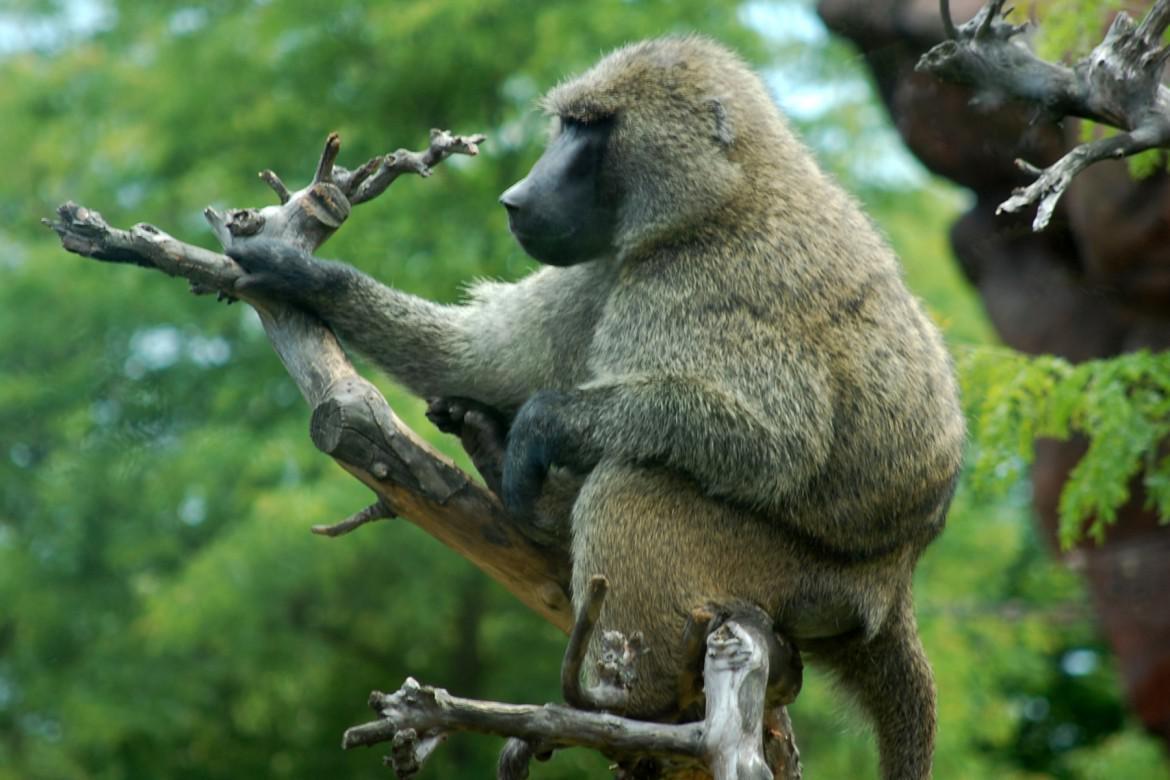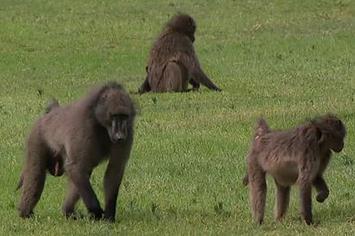The first image is the image on the left, the second image is the image on the right. Evaluate the accuracy of this statement regarding the images: "There are at least two monkeys in the image on the right.". Is it true? Answer yes or no. Yes. The first image is the image on the left, the second image is the image on the right. Assess this claim about the two images: "An image shows exactly one baboon, which is walking on all fours on the ground.". Correct or not? Answer yes or no. No. 